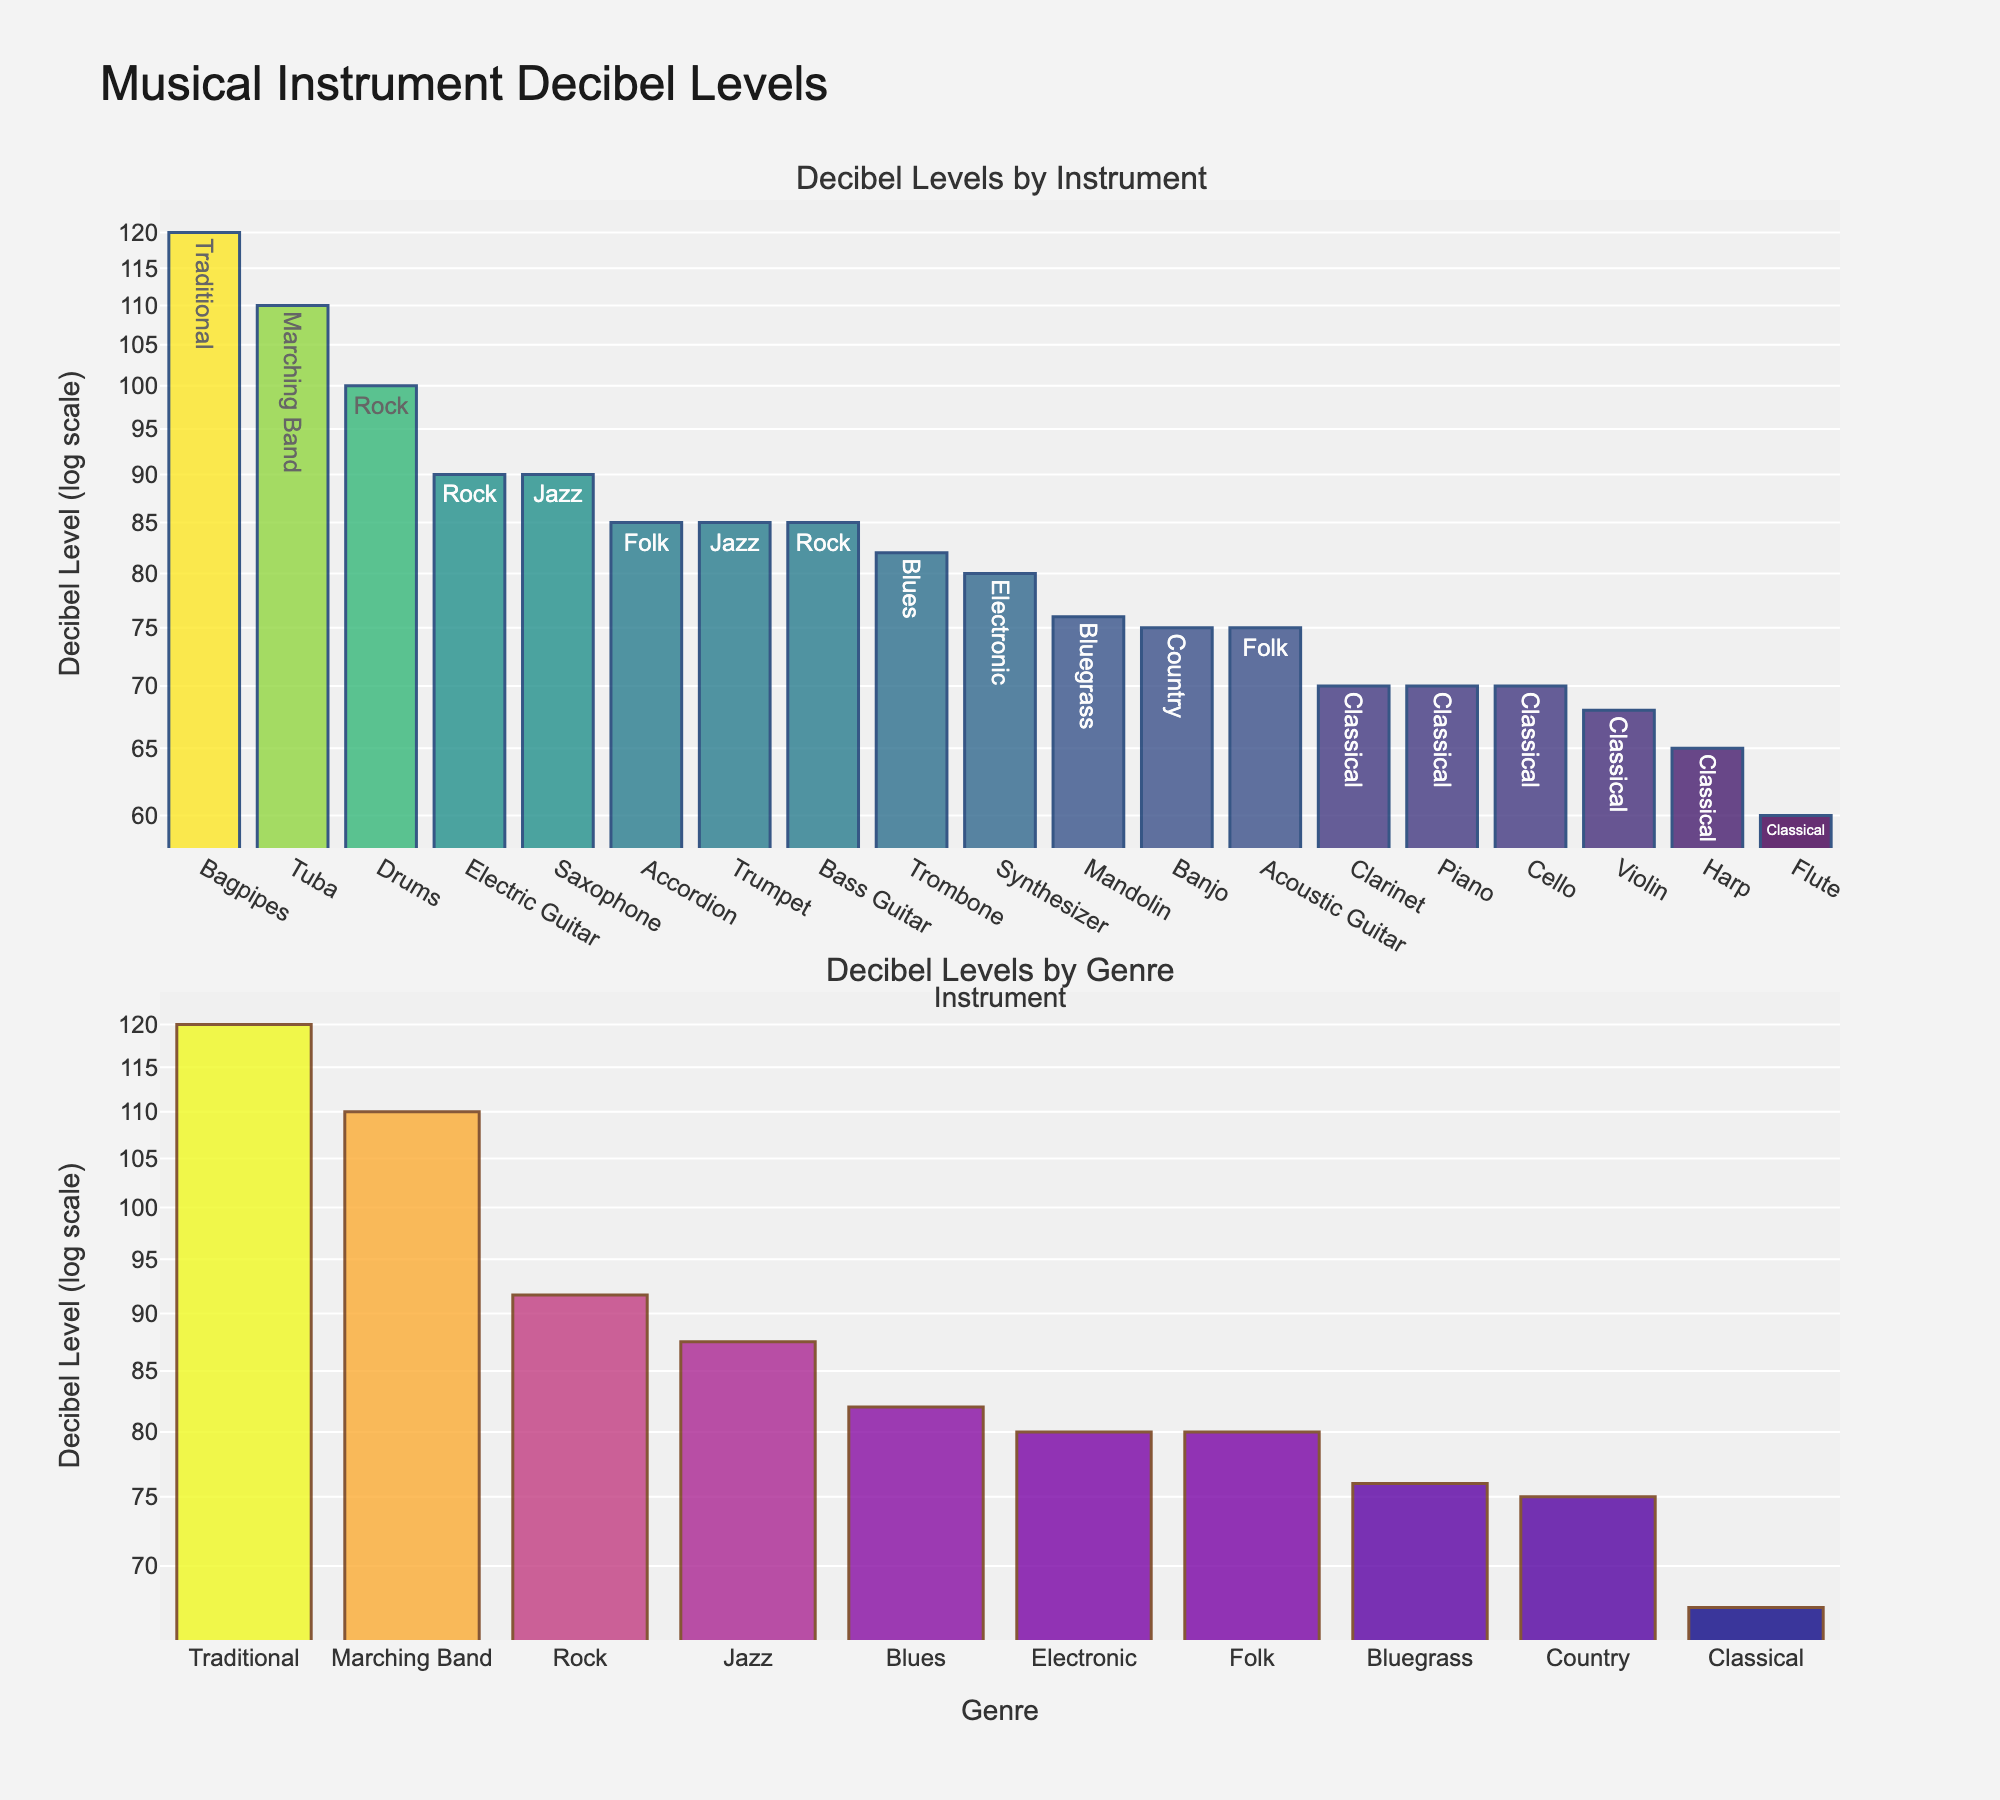Which instrument has the highest decibel level? Look at the first subplot "Decibel Levels by Instrument". The bar with the highest value represents the instrument with the highest decibel level. It is Bagpipes with a decibel level of 120.
Answer: Bagpipes Which genre has the lowest average decibel level? In the second subplot "Decibel Levels by Genre", identify the bar with the lowest value. The genre with the lowest average decibel level is Classical, with an average of approximately 67.6 decibels.
Answer: Classical What is the decibel level range for classical music instruments? Identify all classical music instruments in the first subplot: Piano (70), Violin (68), Flute (60), Cello (70), Harp (65), and Clarinet (70). The range is from 60 to 70 decibels.
Answer: 60-70 decibels How does the decibel level of the Trumpet compare to that of the Synthesizer? In the first subplot, compare the height of the bars for Trumpet (85) and Synthesizer (80). The Trumpet has a higher decibel level than the Synthesizer.
Answer: Trumpet is higher What is the average decibel level across all instruments in the Folk genre? Find the instruments in the Folk genre in the first subplot: Acoustic Guitar (75) and Accordion (85). The average is (75 + 85) / 2 = 80.
Answer: 80 decibels Which genre has the highest average decibel level? Look at the second subplot "Decibel Levels by Genre". The bar with the highest value represents the genre with the highest average decibel level. It is Traditional with an average decibel level of 120.
Answer: Traditional What is the difference in decibel level between Drums and Electric Guitar in the Rock genre? In the first subplot, find Drums (100) and Electric Guitar (90) in the Rock genre. The difference is 100 - 90 = 10 decibels.
Answer: 10 decibels How many instruments fall within the decibel level range of 60 to 80? Count the number of bars in the first subplot that fall within this range: Acoustic Guitar (75), Piano (70), Violin (68), Flute (60), Synthesizer (80), Cello (70), Harp (65), Banjo (75), Mandolin (76). There are 9 instruments.
Answer: 9 instruments What is the average decibel level of all instruments combined? Sum up the decibel levels of all instruments and divide by the total number of instruments: (75+90+70+100+68+85+60+80+85+70+90+82+65+70+110+120+85+75+76)/19 = 83.16.
Answer: 83.16 decibels 